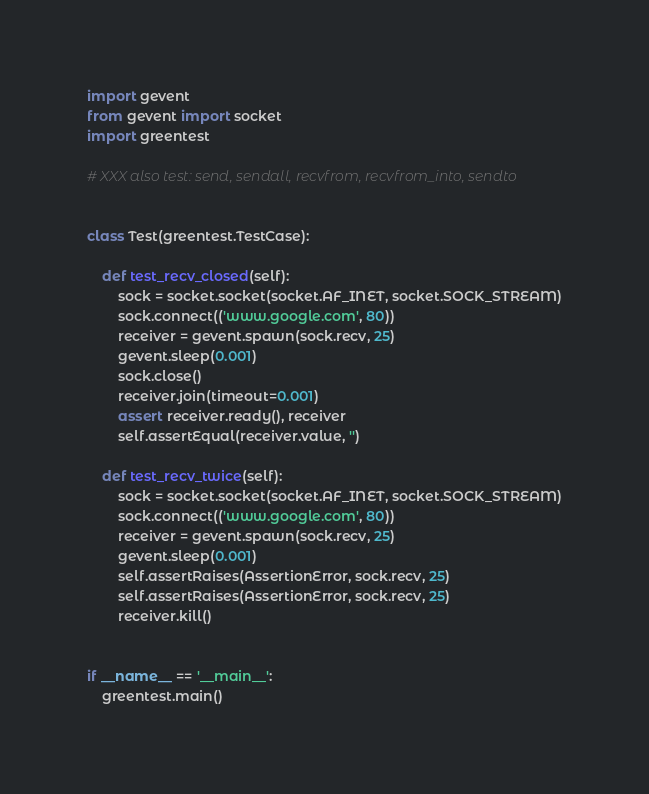Convert code to text. <code><loc_0><loc_0><loc_500><loc_500><_Python_>import gevent
from gevent import socket
import greentest

# XXX also test: send, sendall, recvfrom, recvfrom_into, sendto


class Test(greentest.TestCase):

    def test_recv_closed(self):
        sock = socket.socket(socket.AF_INET, socket.SOCK_STREAM)
        sock.connect(('www.google.com', 80))
        receiver = gevent.spawn(sock.recv, 25)
        gevent.sleep(0.001)
        sock.close()
        receiver.join(timeout=0.001)
        assert receiver.ready(), receiver
        self.assertEqual(receiver.value, '')

    def test_recv_twice(self):
        sock = socket.socket(socket.AF_INET, socket.SOCK_STREAM)
        sock.connect(('www.google.com', 80))
        receiver = gevent.spawn(sock.recv, 25)
        gevent.sleep(0.001)
        self.assertRaises(AssertionError, sock.recv, 25)
        self.assertRaises(AssertionError, sock.recv, 25)
        receiver.kill()


if __name__ == '__main__':
    greentest.main()
</code> 